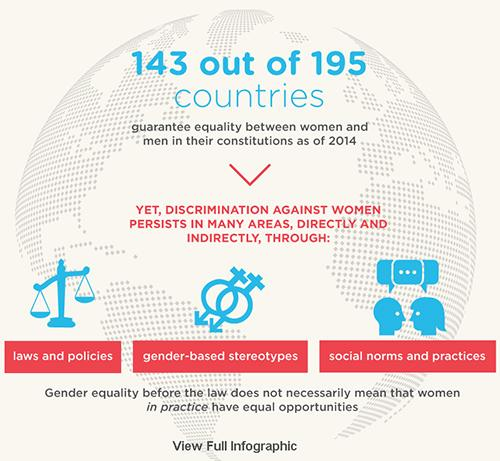Specify some key components in this picture. Out of 195 countries, 52 do not guarantee equality between women and men. Discrimination persists in areas such as laws and policies, gender-based stereotypes, and social norms and practices. The area referred to by the weighing machine is laws and policies. 